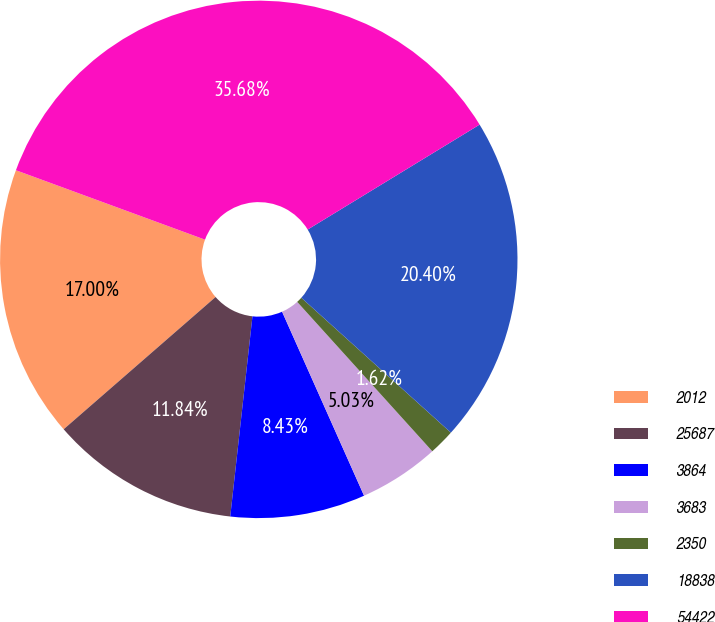Convert chart. <chart><loc_0><loc_0><loc_500><loc_500><pie_chart><fcel>2012<fcel>25687<fcel>3864<fcel>3683<fcel>2350<fcel>18838<fcel>54422<nl><fcel>17.0%<fcel>11.84%<fcel>8.43%<fcel>5.03%<fcel>1.62%<fcel>20.4%<fcel>35.68%<nl></chart> 